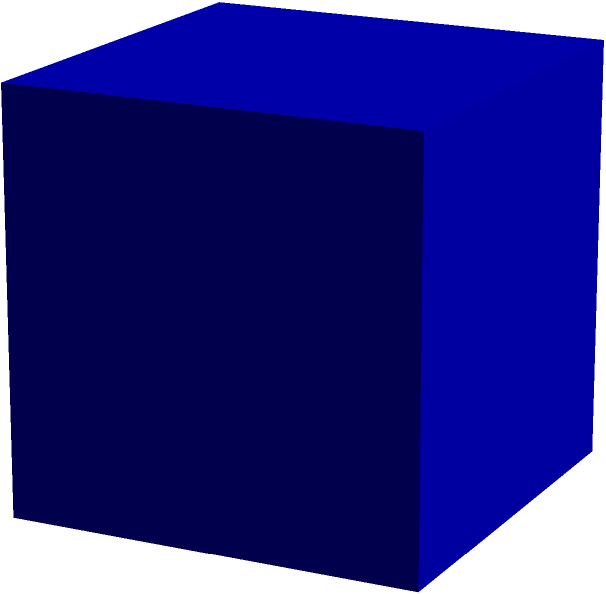As part of your virtual community support group, you're sharing a mindfulness exercise involving visualization. You ask members to imagine a cube and calculate its volume. If the total surface area of the cube is 54 square units, what is its volume? Let's approach this step-by-step:

1) First, recall that a cube has 6 identical square faces.

2) If we denote the length of one edge as $a$, then the surface area of one face is $a^2$.

3) The total surface area is therefore $6a^2$.

4) We're given that the total surface area is 54 square units. So we can write:

   $6a^2 = 54$

5) Solving for $a$:
   
   $a^2 = 54 \div 6 = 9$
   
   $a = \sqrt{9} = 3$

6) Now that we know the length of one edge, we can calculate the volume.

7) The volume of a cube is given by $a^3$.

8) Therefore, the volume is:

   $V = a^3 = 3^3 = 27$

So, the volume of the cube is 27 cubic units.

This exercise can help group members focus their minds on a specific task, promoting mental clarity and potentially providing a brief respite from MS-related concerns.
Answer: 27 cubic units 